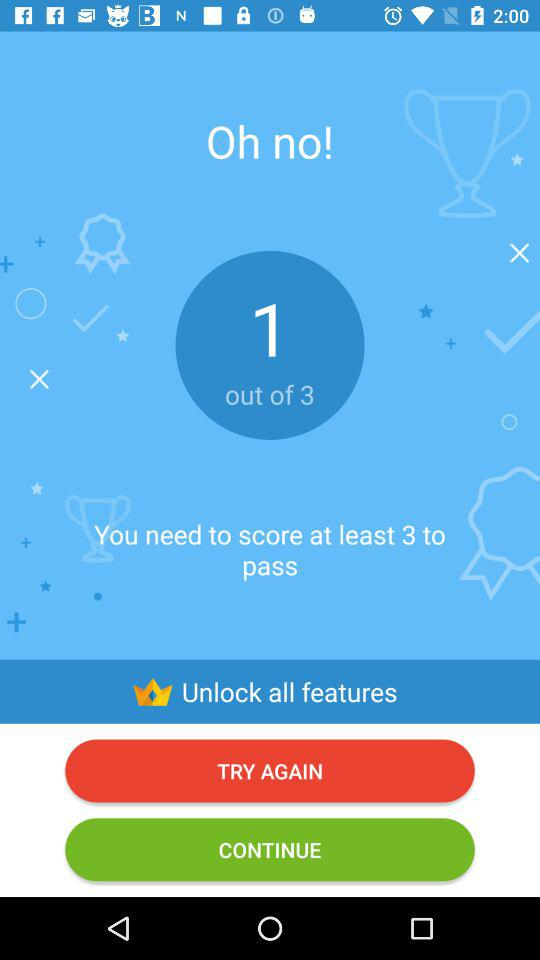How many points do you have?
Answer the question using a single word or phrase. 1 